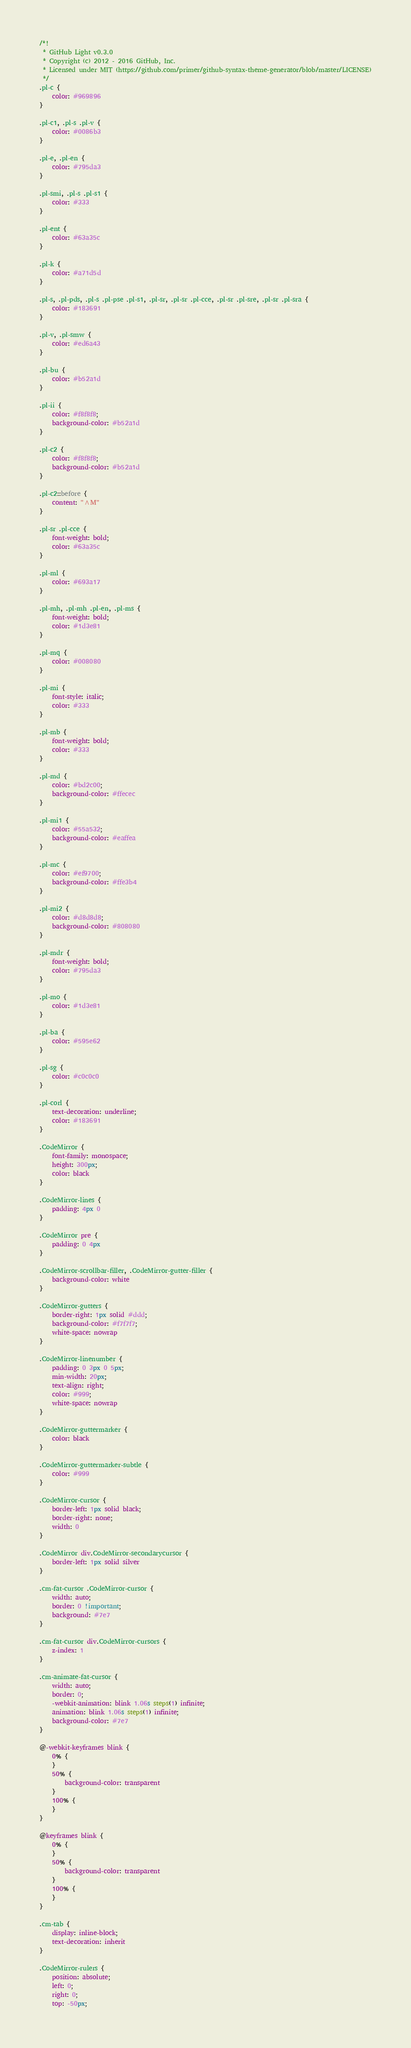Convert code to text. <code><loc_0><loc_0><loc_500><loc_500><_CSS_>/*!
 * GitHub Light v0.3.0
 * Copyright (c) 2012 - 2016 GitHub, Inc.
 * Licensed under MIT (https://github.com/primer/github-syntax-theme-generator/blob/master/LICENSE)
 */
.pl-c {
    color: #969896
}

.pl-c1, .pl-s .pl-v {
    color: #0086b3
}

.pl-e, .pl-en {
    color: #795da3
}

.pl-smi, .pl-s .pl-s1 {
    color: #333
}

.pl-ent {
    color: #63a35c
}

.pl-k {
    color: #a71d5d
}

.pl-s, .pl-pds, .pl-s .pl-pse .pl-s1, .pl-sr, .pl-sr .pl-cce, .pl-sr .pl-sre, .pl-sr .pl-sra {
    color: #183691
}

.pl-v, .pl-smw {
    color: #ed6a43
}

.pl-bu {
    color: #b52a1d
}

.pl-ii {
    color: #f8f8f8;
    background-color: #b52a1d
}

.pl-c2 {
    color: #f8f8f8;
    background-color: #b52a1d
}

.pl-c2::before {
    content: "^M"
}

.pl-sr .pl-cce {
    font-weight: bold;
    color: #63a35c
}

.pl-ml {
    color: #693a17
}

.pl-mh, .pl-mh .pl-en, .pl-ms {
    font-weight: bold;
    color: #1d3e81
}

.pl-mq {
    color: #008080
}

.pl-mi {
    font-style: italic;
    color: #333
}

.pl-mb {
    font-weight: bold;
    color: #333
}

.pl-md {
    color: #bd2c00;
    background-color: #ffecec
}

.pl-mi1 {
    color: #55a532;
    background-color: #eaffea
}

.pl-mc {
    color: #ef9700;
    background-color: #ffe3b4
}

.pl-mi2 {
    color: #d8d8d8;
    background-color: #808080
}

.pl-mdr {
    font-weight: bold;
    color: #795da3
}

.pl-mo {
    color: #1d3e81
}

.pl-ba {
    color: #595e62
}

.pl-sg {
    color: #c0c0c0
}

.pl-corl {
    text-decoration: underline;
    color: #183691
}

.CodeMirror {
    font-family: monospace;
    height: 300px;
    color: black
}

.CodeMirror-lines {
    padding: 4px 0
}

.CodeMirror pre {
    padding: 0 4px
}

.CodeMirror-scrollbar-filler, .CodeMirror-gutter-filler {
    background-color: white
}

.CodeMirror-gutters {
    border-right: 1px solid #ddd;
    background-color: #f7f7f7;
    white-space: nowrap
}

.CodeMirror-linenumber {
    padding: 0 3px 0 5px;
    min-width: 20px;
    text-align: right;
    color: #999;
    white-space: nowrap
}

.CodeMirror-guttermarker {
    color: black
}

.CodeMirror-guttermarker-subtle {
    color: #999
}

.CodeMirror-cursor {
    border-left: 1px solid black;
    border-right: none;
    width: 0
}

.CodeMirror div.CodeMirror-secondarycursor {
    border-left: 1px solid silver
}

.cm-fat-cursor .CodeMirror-cursor {
    width: auto;
    border: 0 !important;
    background: #7e7
}

.cm-fat-cursor div.CodeMirror-cursors {
    z-index: 1
}

.cm-animate-fat-cursor {
    width: auto;
    border: 0;
    -webkit-animation: blink 1.06s steps(1) infinite;
    animation: blink 1.06s steps(1) infinite;
    background-color: #7e7
}

@-webkit-keyframes blink {
    0% {
    }
    50% {
        background-color: transparent
    }
    100% {
    }
}

@keyframes blink {
    0% {
    }
    50% {
        background-color: transparent
    }
    100% {
    }
}

.cm-tab {
    display: inline-block;
    text-decoration: inherit
}

.CodeMirror-rulers {
    position: absolute;
    left: 0;
    right: 0;
    top: -50px;</code> 